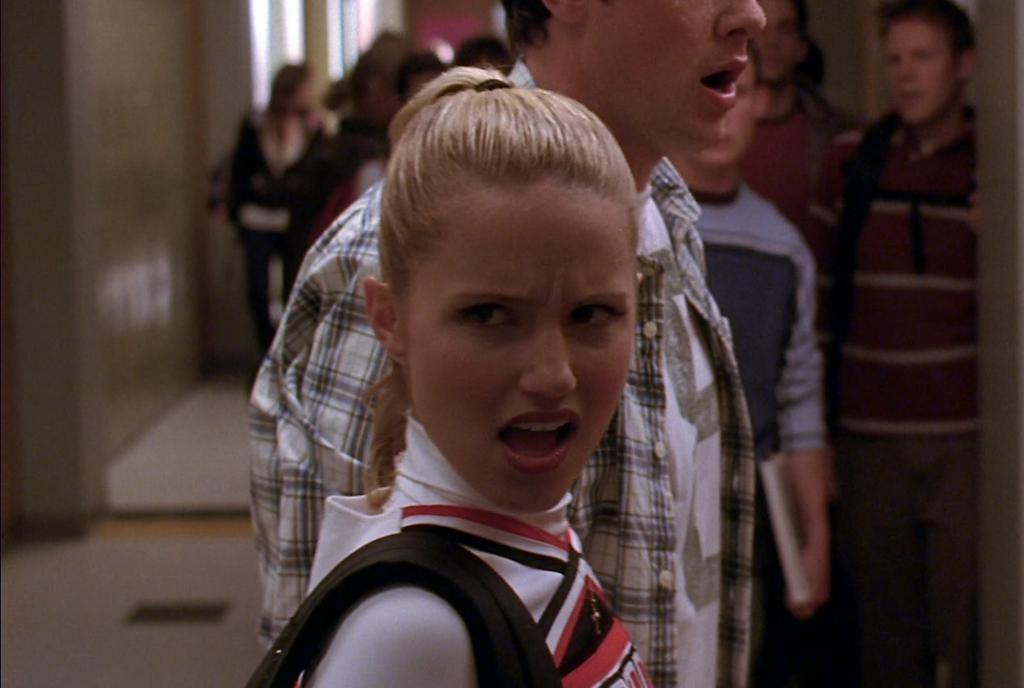How would you summarize this image in a sentence or two? In this picture we can see a girl and in the background we can see a group of people, wall and some objects. 